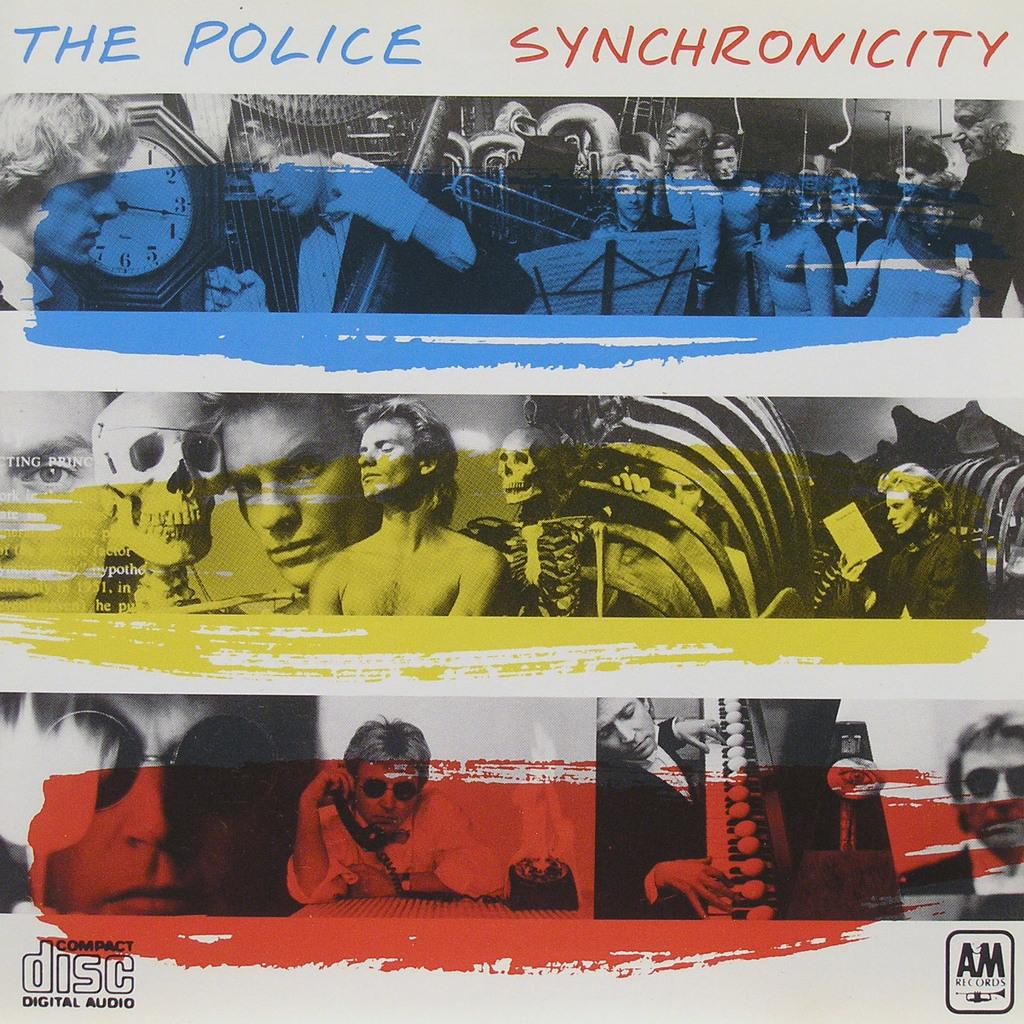<image>
Render a clear and concise summary of the photo. an album cover that has the police on it 